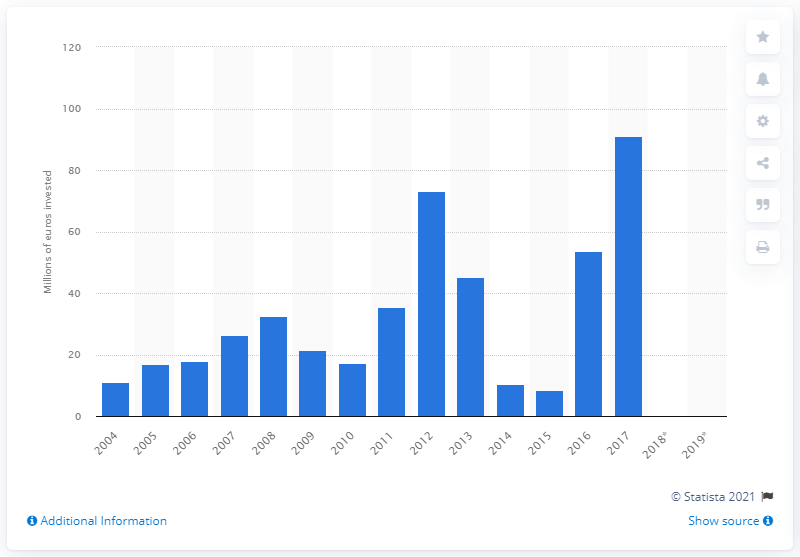Draw attention to some important aspects in this diagram. In 2017, Turkey's highest investment in maritime port infrastructure was approximately 91.2 billion Turkish lira. In 2015, a total of $8.4 billion was invested in sea port infrastructure. 